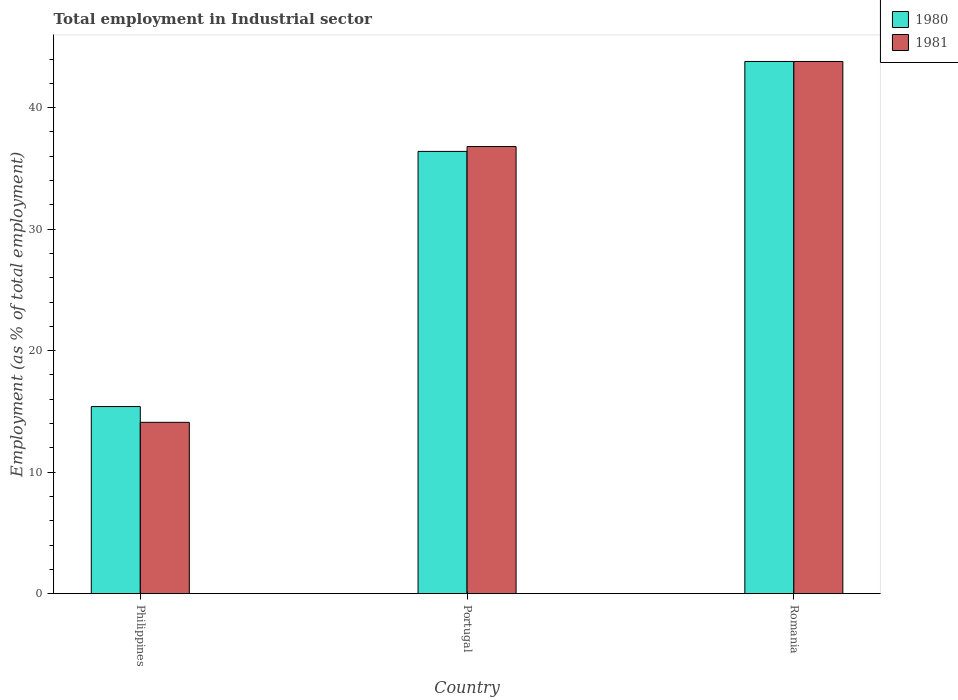How many different coloured bars are there?
Keep it short and to the point. 2. How many groups of bars are there?
Make the answer very short. 3. What is the label of the 1st group of bars from the left?
Your answer should be very brief. Philippines. In how many cases, is the number of bars for a given country not equal to the number of legend labels?
Provide a short and direct response. 0. What is the employment in industrial sector in 1980 in Philippines?
Provide a succinct answer. 15.4. Across all countries, what is the maximum employment in industrial sector in 1980?
Offer a terse response. 43.8. Across all countries, what is the minimum employment in industrial sector in 1981?
Give a very brief answer. 14.1. In which country was the employment in industrial sector in 1980 maximum?
Ensure brevity in your answer.  Romania. What is the total employment in industrial sector in 1980 in the graph?
Give a very brief answer. 95.6. What is the difference between the employment in industrial sector in 1981 in Romania and the employment in industrial sector in 1980 in Philippines?
Your answer should be very brief. 28.4. What is the average employment in industrial sector in 1981 per country?
Offer a terse response. 31.57. What is the difference between the employment in industrial sector of/in 1980 and employment in industrial sector of/in 1981 in Portugal?
Make the answer very short. -0.4. What is the ratio of the employment in industrial sector in 1980 in Portugal to that in Romania?
Your response must be concise. 0.83. Is the difference between the employment in industrial sector in 1980 in Portugal and Romania greater than the difference between the employment in industrial sector in 1981 in Portugal and Romania?
Ensure brevity in your answer.  No. What is the difference between the highest and the second highest employment in industrial sector in 1981?
Your response must be concise. 7. What is the difference between the highest and the lowest employment in industrial sector in 1980?
Your response must be concise. 28.4. In how many countries, is the employment in industrial sector in 1980 greater than the average employment in industrial sector in 1980 taken over all countries?
Offer a very short reply. 2. Is the sum of the employment in industrial sector in 1981 in Portugal and Romania greater than the maximum employment in industrial sector in 1980 across all countries?
Keep it short and to the point. Yes. Are all the bars in the graph horizontal?
Offer a terse response. No. Where does the legend appear in the graph?
Offer a very short reply. Top right. What is the title of the graph?
Offer a very short reply. Total employment in Industrial sector. What is the label or title of the X-axis?
Provide a short and direct response. Country. What is the label or title of the Y-axis?
Give a very brief answer. Employment (as % of total employment). What is the Employment (as % of total employment) in 1980 in Philippines?
Offer a very short reply. 15.4. What is the Employment (as % of total employment) in 1981 in Philippines?
Give a very brief answer. 14.1. What is the Employment (as % of total employment) in 1980 in Portugal?
Provide a succinct answer. 36.4. What is the Employment (as % of total employment) in 1981 in Portugal?
Provide a short and direct response. 36.8. What is the Employment (as % of total employment) of 1980 in Romania?
Ensure brevity in your answer.  43.8. What is the Employment (as % of total employment) of 1981 in Romania?
Your answer should be very brief. 43.8. Across all countries, what is the maximum Employment (as % of total employment) of 1980?
Make the answer very short. 43.8. Across all countries, what is the maximum Employment (as % of total employment) in 1981?
Ensure brevity in your answer.  43.8. Across all countries, what is the minimum Employment (as % of total employment) in 1980?
Offer a very short reply. 15.4. Across all countries, what is the minimum Employment (as % of total employment) of 1981?
Keep it short and to the point. 14.1. What is the total Employment (as % of total employment) of 1980 in the graph?
Your answer should be compact. 95.6. What is the total Employment (as % of total employment) of 1981 in the graph?
Your answer should be compact. 94.7. What is the difference between the Employment (as % of total employment) in 1980 in Philippines and that in Portugal?
Keep it short and to the point. -21. What is the difference between the Employment (as % of total employment) of 1981 in Philippines and that in Portugal?
Give a very brief answer. -22.7. What is the difference between the Employment (as % of total employment) of 1980 in Philippines and that in Romania?
Offer a terse response. -28.4. What is the difference between the Employment (as % of total employment) in 1981 in Philippines and that in Romania?
Your answer should be compact. -29.7. What is the difference between the Employment (as % of total employment) of 1980 in Philippines and the Employment (as % of total employment) of 1981 in Portugal?
Your answer should be very brief. -21.4. What is the difference between the Employment (as % of total employment) of 1980 in Philippines and the Employment (as % of total employment) of 1981 in Romania?
Provide a short and direct response. -28.4. What is the difference between the Employment (as % of total employment) of 1980 in Portugal and the Employment (as % of total employment) of 1981 in Romania?
Offer a very short reply. -7.4. What is the average Employment (as % of total employment) of 1980 per country?
Provide a succinct answer. 31.87. What is the average Employment (as % of total employment) of 1981 per country?
Your response must be concise. 31.57. What is the difference between the Employment (as % of total employment) of 1980 and Employment (as % of total employment) of 1981 in Philippines?
Offer a terse response. 1.3. What is the difference between the Employment (as % of total employment) of 1980 and Employment (as % of total employment) of 1981 in Portugal?
Keep it short and to the point. -0.4. What is the difference between the Employment (as % of total employment) of 1980 and Employment (as % of total employment) of 1981 in Romania?
Your answer should be compact. 0. What is the ratio of the Employment (as % of total employment) in 1980 in Philippines to that in Portugal?
Ensure brevity in your answer.  0.42. What is the ratio of the Employment (as % of total employment) in 1981 in Philippines to that in Portugal?
Give a very brief answer. 0.38. What is the ratio of the Employment (as % of total employment) in 1980 in Philippines to that in Romania?
Provide a short and direct response. 0.35. What is the ratio of the Employment (as % of total employment) in 1981 in Philippines to that in Romania?
Provide a succinct answer. 0.32. What is the ratio of the Employment (as % of total employment) of 1980 in Portugal to that in Romania?
Ensure brevity in your answer.  0.83. What is the ratio of the Employment (as % of total employment) in 1981 in Portugal to that in Romania?
Your answer should be compact. 0.84. What is the difference between the highest and the second highest Employment (as % of total employment) of 1980?
Keep it short and to the point. 7.4. What is the difference between the highest and the lowest Employment (as % of total employment) of 1980?
Offer a very short reply. 28.4. What is the difference between the highest and the lowest Employment (as % of total employment) of 1981?
Provide a succinct answer. 29.7. 